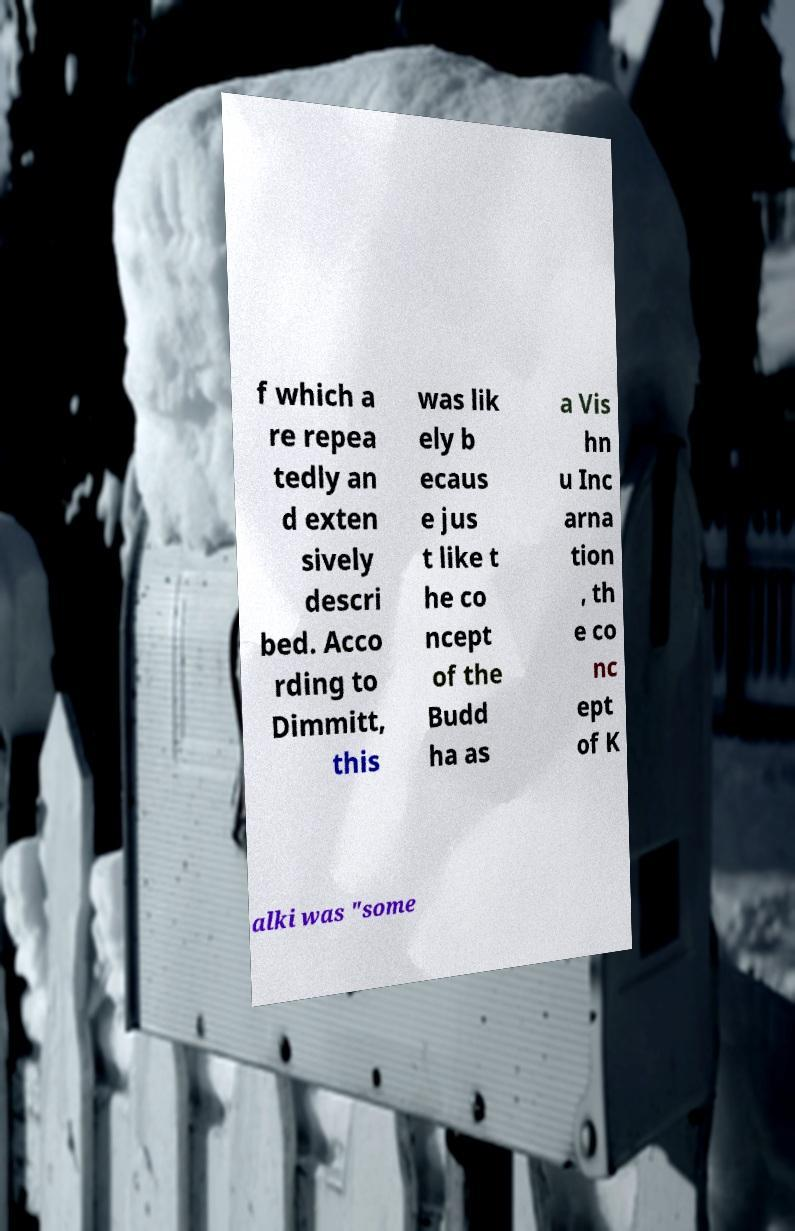Please read and relay the text visible in this image. What does it say? f which a re repea tedly an d exten sively descri bed. Acco rding to Dimmitt, this was lik ely b ecaus e jus t like t he co ncept of the Budd ha as a Vis hn u Inc arna tion , th e co nc ept of K alki was "some 